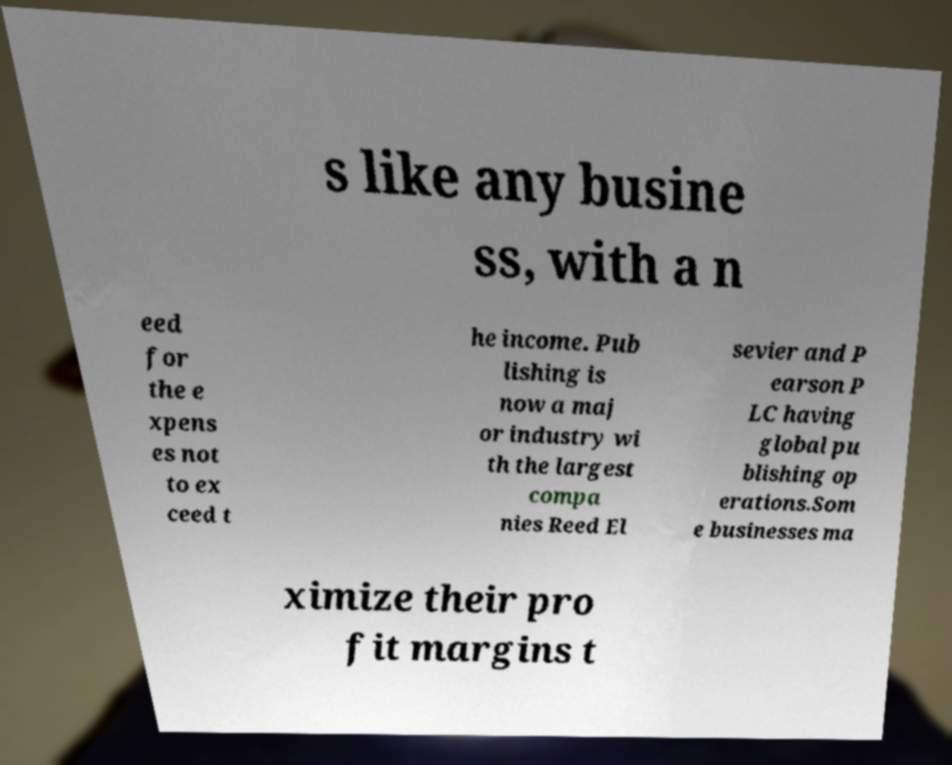I need the written content from this picture converted into text. Can you do that? s like any busine ss, with a n eed for the e xpens es not to ex ceed t he income. Pub lishing is now a maj or industry wi th the largest compa nies Reed El sevier and P earson P LC having global pu blishing op erations.Som e businesses ma ximize their pro fit margins t 